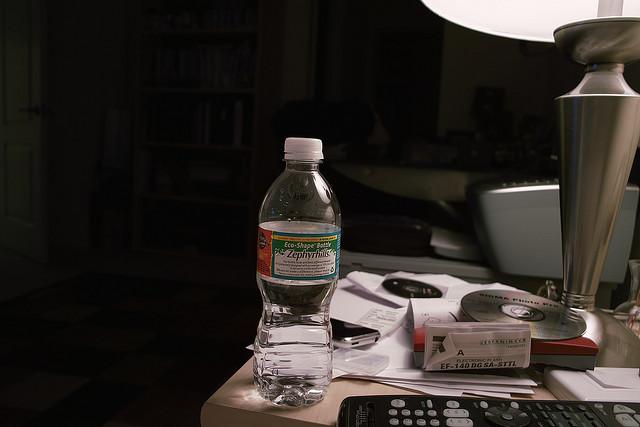What color is the bottle?
Answer briefly. Clear. Is there a cd in the photo?
Quick response, please. Yes. How much water is inside the bottle?
Short answer required. Half. What is inside of the plastic bottle?
Write a very short answer. Water. Where is the water bottle?
Be succinct. Table. 